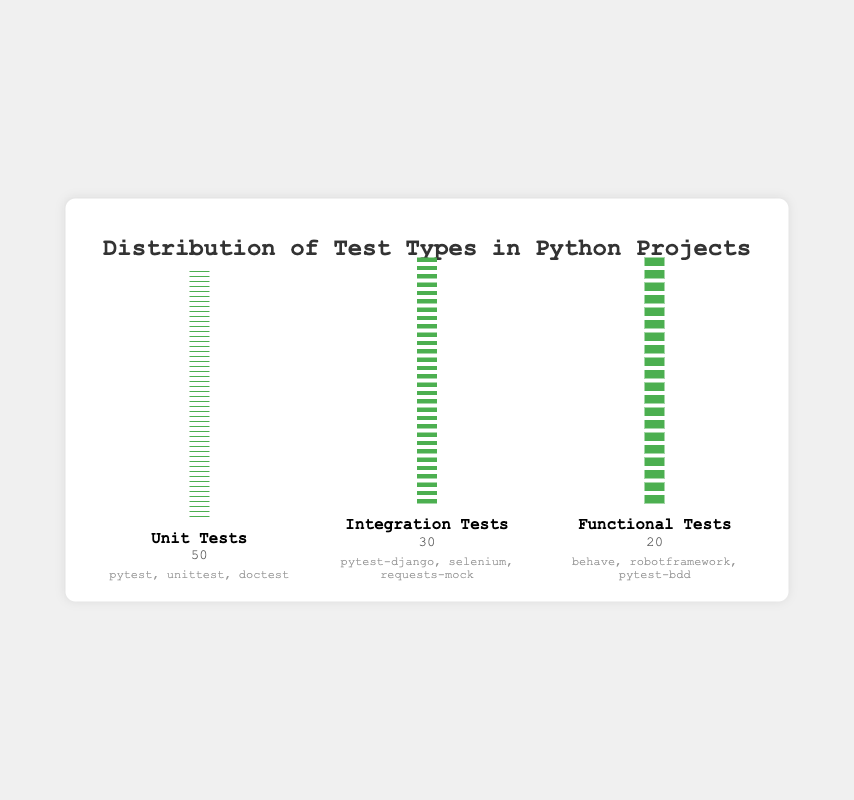What is the title of the isotype plot? Look at the large, bold text centered at the top of the figure. The title is "Distribution of Test Types in Python Projects".
Answer: Distribution of Test Types in Python Projects How many unit tests are represented in the plot? Unit tests are represented by small green squares underneath the "Unit Tests" label. The count of unit tests is stated directly below this label.
Answer: 50 Which test type has the fewest examples shown in the figure? Each test type section lists examples directly under the count. Compare the number of examples listed for each test type. Functional tests have "behave", "robotframework", and "pytest-bdd".
Answer: Functional Tests What is the total number of tests represented in the plot? To find the total number, sum the counts of each test type. Unit Tests: 50, Integration Tests: 30, Functional Tests: 20. So, 50 + 30 + 20 = 100
Answer: 100 How many more unit tests are there compared to functional tests? Subtract the count of functional tests from the count of unit tests. Unit Tests: 50, Functional Tests: 20. So, 50 - 20 = 30
Answer: 30 Which test type uses "selenium" as an example? The examples for each test type are listed directly under the count label. Selenium is listed under Integration Tests.
Answer: Integration Tests What proportion of the tests are integration tests? Calculate the proportion by dividing the number of integration tests by the total number of tests. Integration Tests: 30, Total Tests: 100. So, 30/100 = 0.3 or 30%
Answer: 30% Which test type has the largest number of tests? Compare the counts under each test type. Unit Tests have 50, which is the highest.
Answer: Unit Tests How many tests are there in the unit and integration categories combined? Add the counts of unit tests and integration tests. Unit Tests: 50, Integration Tests: 30. So, 50 + 30 = 80
Answer: 80 Is the count of functional tests less than half of the count of unit tests? Calculate half of the count of unit tests and compare it with the functional tests count. Half of unit tests (50) is 25. Functional tests count is 20. Since 20 < 25, the statement is true.
Answer: Yes 